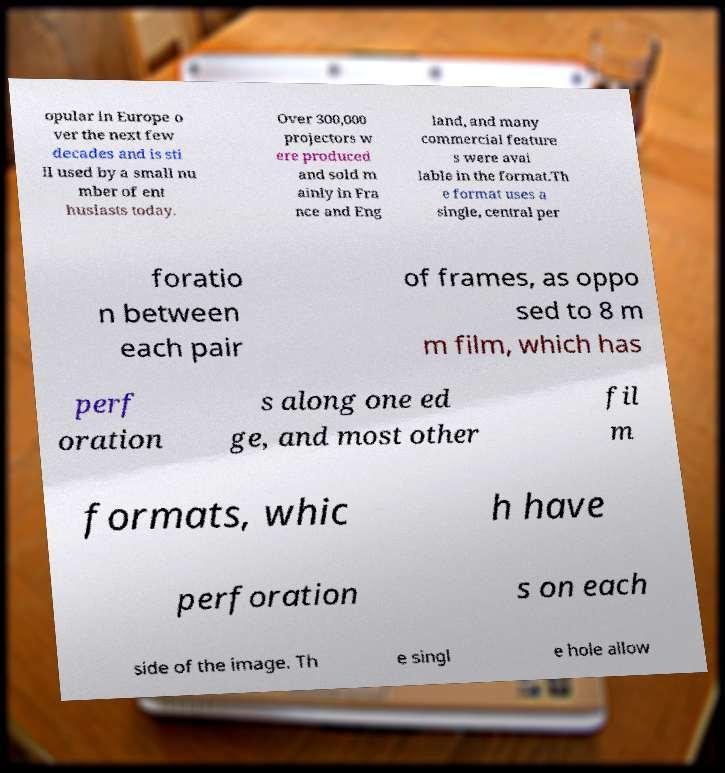Could you assist in decoding the text presented in this image and type it out clearly? opular in Europe o ver the next few decades and is sti ll used by a small nu mber of ent husiasts today. Over 300,000 projectors w ere produced and sold m ainly in Fra nce and Eng land, and many commercial feature s were avai lable in the format.Th e format uses a single, central per foratio n between each pair of frames, as oppo sed to 8 m m film, which has perf oration s along one ed ge, and most other fil m formats, whic h have perforation s on each side of the image. Th e singl e hole allow 